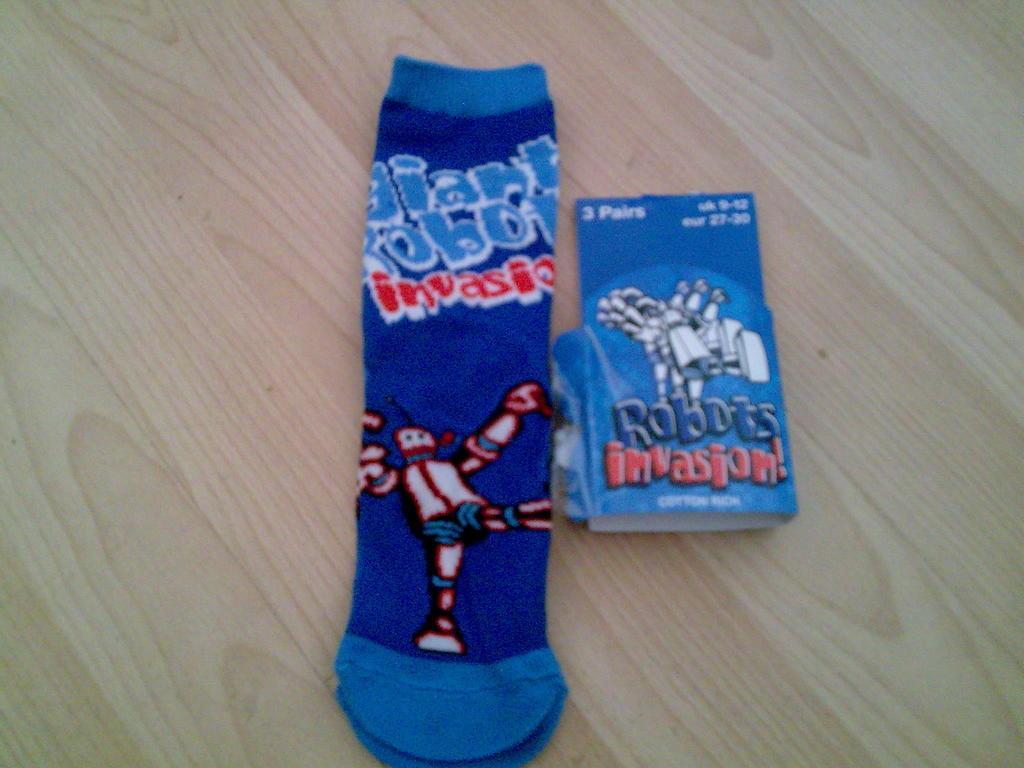Can you describe this image briefly? In this picture we can see a table. On the table there is a blue colour socks. On the socks we can see a cartoon and beside that there is a paper stating "Robots invasion". 